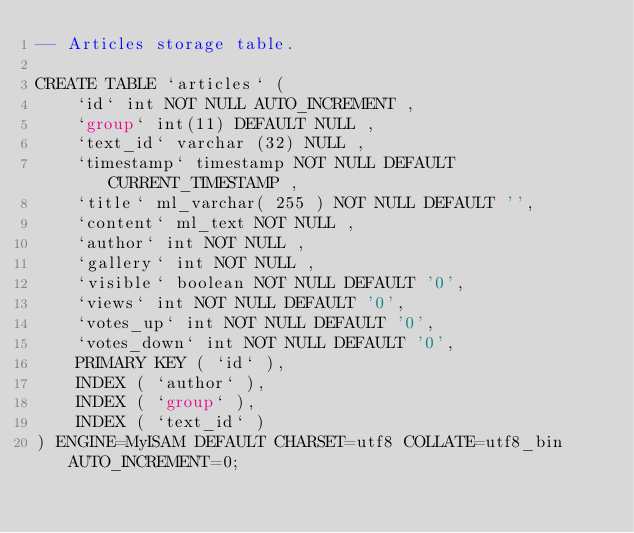<code> <loc_0><loc_0><loc_500><loc_500><_SQL_>-- Articles storage table.

CREATE TABLE `articles` (
	`id` int NOT NULL AUTO_INCREMENT ,
	`group` int(11) DEFAULT NULL ,
	`text_id` varchar (32) NULL ,
	`timestamp` timestamp NOT NULL DEFAULT CURRENT_TIMESTAMP ,
	`title` ml_varchar( 255 ) NOT NULL DEFAULT '',
	`content` ml_text NOT NULL ,
	`author` int NOT NULL ,
	`gallery` int NOT NULL ,
	`visible` boolean NOT NULL DEFAULT '0',
	`views` int NOT NULL DEFAULT '0',
	`votes_up` int NOT NULL DEFAULT '0',
	`votes_down` int NOT NULL DEFAULT '0',
	PRIMARY KEY ( `id` ),
	INDEX ( `author` ),
	INDEX ( `group` ),
	INDEX ( `text_id` )
) ENGINE=MyISAM DEFAULT CHARSET=utf8 COLLATE=utf8_bin AUTO_INCREMENT=0;
</code> 